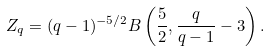Convert formula to latex. <formula><loc_0><loc_0><loc_500><loc_500>Z _ { q } = ( q - 1 ) ^ { - 5 / 2 } B \left ( \frac { 5 } { 2 } , \frac { q } { q - 1 } - 3 \right ) .</formula> 